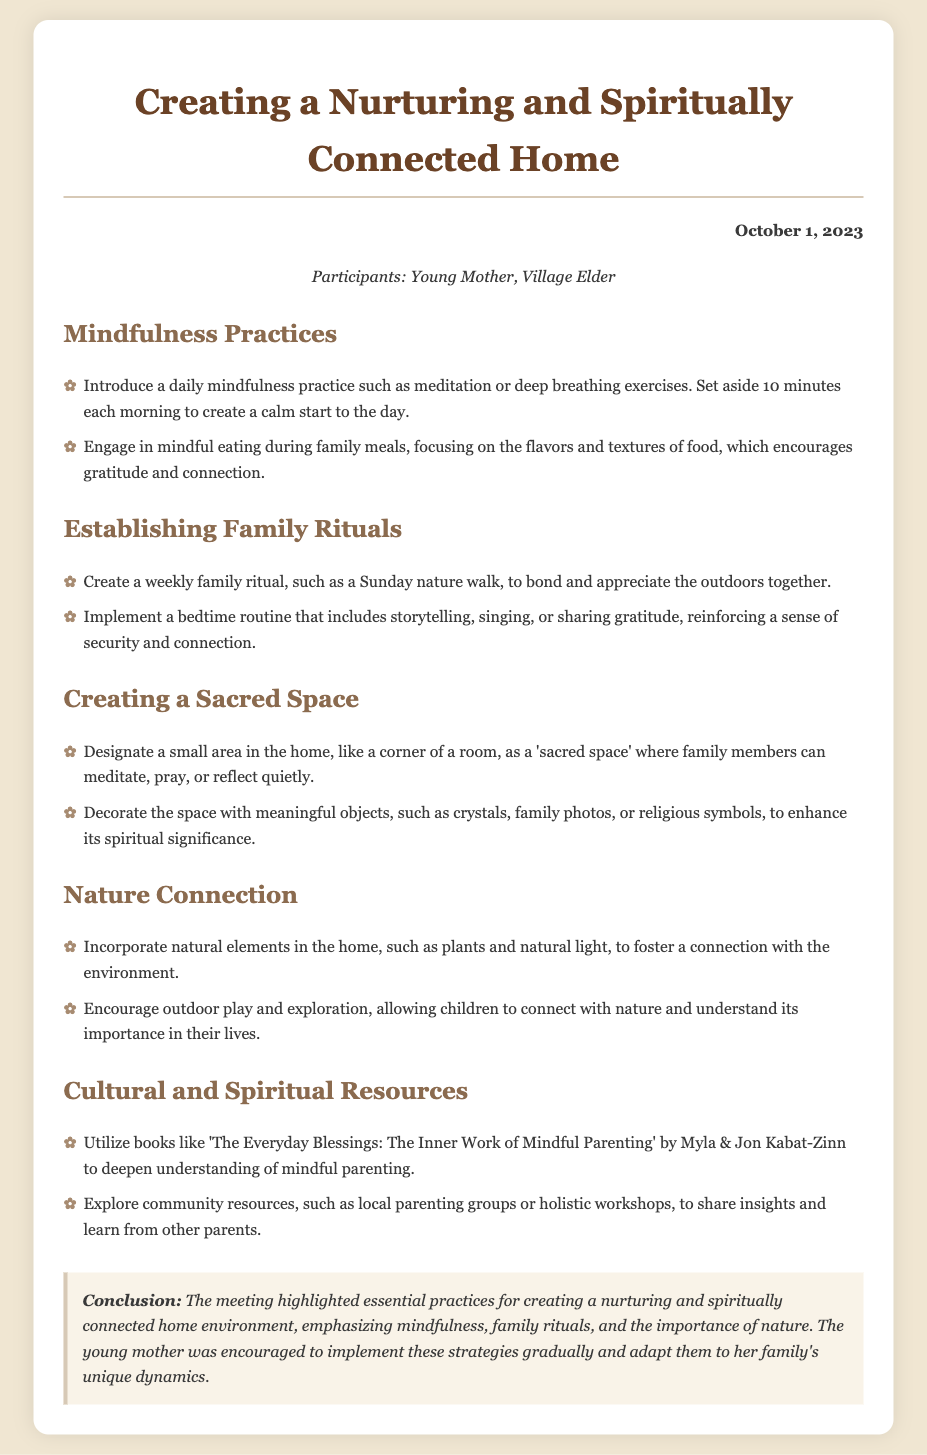What is the date of the meeting? The date of the meeting is listed at the top of the document under the date section.
Answer: October 1, 2023 Who participated in the meeting? The participants of the meeting are mentioned in the participants section, highlighting who was there.
Answer: Young Mother, Village Elder What is one mindfulness practice suggested for families? One mindfulness practice is mentioned in the mindfulness practices section, focusing on specific daily activities.
Answer: Meditation What is the purpose of creating a sacred space? The purpose of creating a sacred space is described in the section dedicated to it, emphasizing its function in the home.
Answer: Meditate, pray, or reflect quietly Which book is recommended for mindful parenting? A book recommended for deeper understanding of mindful parenting is noted in the cultural and spiritual resources section.
Answer: The Everyday Blessings: The Inner Work of Mindful Parenting What type of outdoor activity is suggested for families? A specific outdoor activity for families is mentioned in the nature connection section, highlighting ways to connect with nature.
Answer: Nature walk What color are the headings in the document? The specific color of the headings can be observed throughout the document in the styled format.
Answer: Brown What is emphasized in the conclusion of the meeting? The conclusion reiterates key themes discussed in the meeting, summarizing the focus on specific practices.
Answer: Mindfulness, family rituals, and the importance of nature 